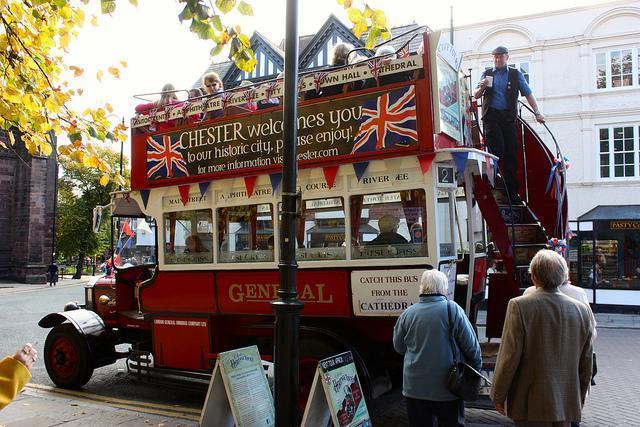How many people are standing on the bus stairs?
Give a very brief answer. 1. How many people can you see?
Give a very brief answer. 4. How many train tracks?
Give a very brief answer. 0. 